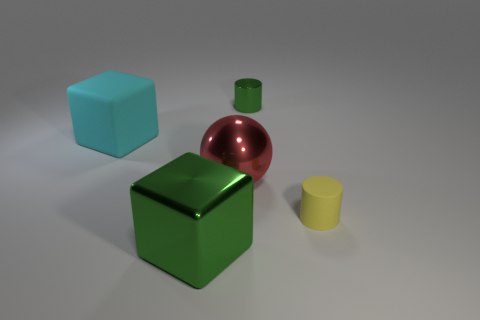What is the size of the other object that is the same color as the small metallic thing?
Keep it short and to the point. Large. What shape is the big thing that is the same color as the small shiny cylinder?
Your answer should be compact. Cube. Does the big red object have the same shape as the green metallic thing behind the tiny yellow cylinder?
Ensure brevity in your answer.  No. What number of other objects are there of the same material as the sphere?
Offer a terse response. 2. What is the color of the large metallic ball that is behind the green shiny thing left of the small thing behind the rubber cube?
Your answer should be very brief. Red. What shape is the big cyan thing behind the rubber object to the right of the small metal object?
Offer a terse response. Cube. Are there more large cyan cubes in front of the large metallic sphere than green metal cubes?
Make the answer very short. No. Do the large cyan object that is on the left side of the small metallic cylinder and the red thing have the same shape?
Keep it short and to the point. No. Is there another object of the same shape as the yellow matte thing?
Your response must be concise. Yes. How many things are either green things in front of the yellow object or large red spheres?
Give a very brief answer. 2. 